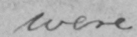What does this handwritten line say? were 